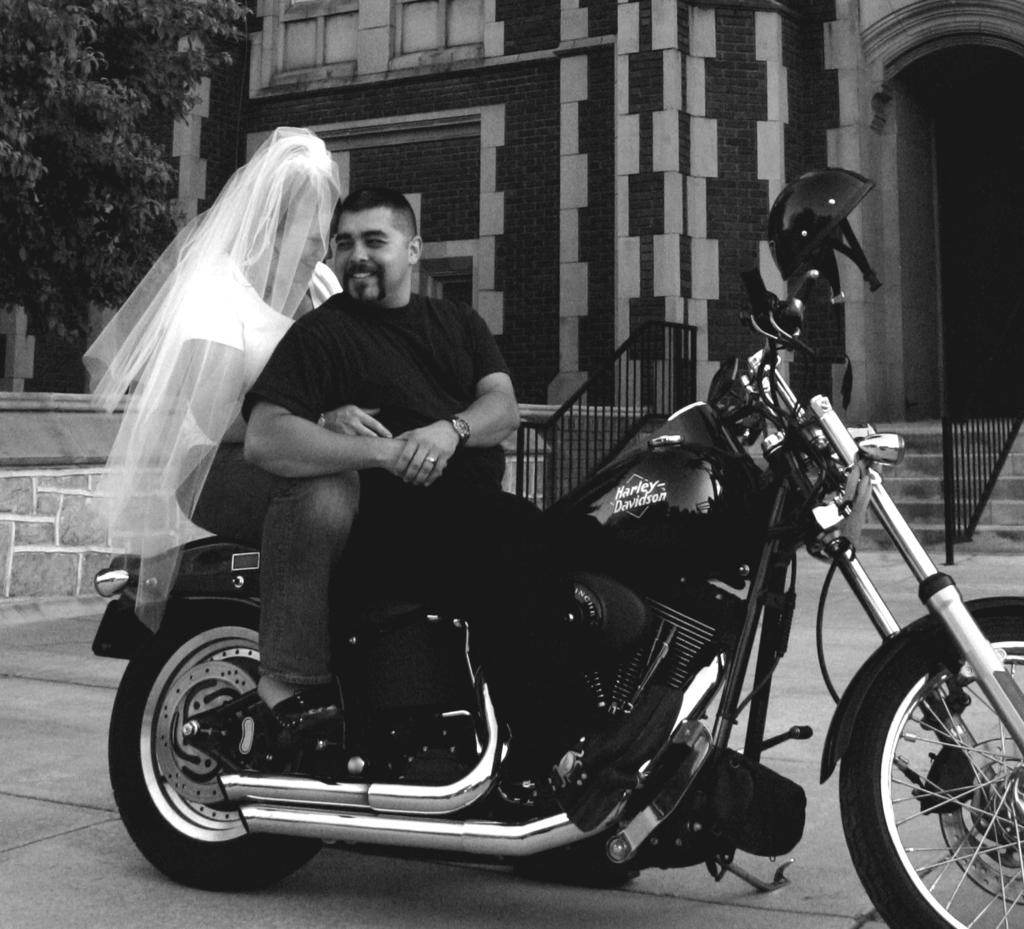How many people are in the image? There is a man and a woman in the image. What are the man and woman doing in the image? The man and woman are sitting on a bike. What is the facial expression of the man and woman? The man and woman are smiling. What can be seen in the background of the image? There are steps, a fence, an arch, a building, and a tree in the background of the image. What type of calculator is the man holding in the image? There is no calculator present in the image. How does the bike grip the road in the image? The bike does not grip the road in the image; it is stationary with the man and woman sitting on it. 